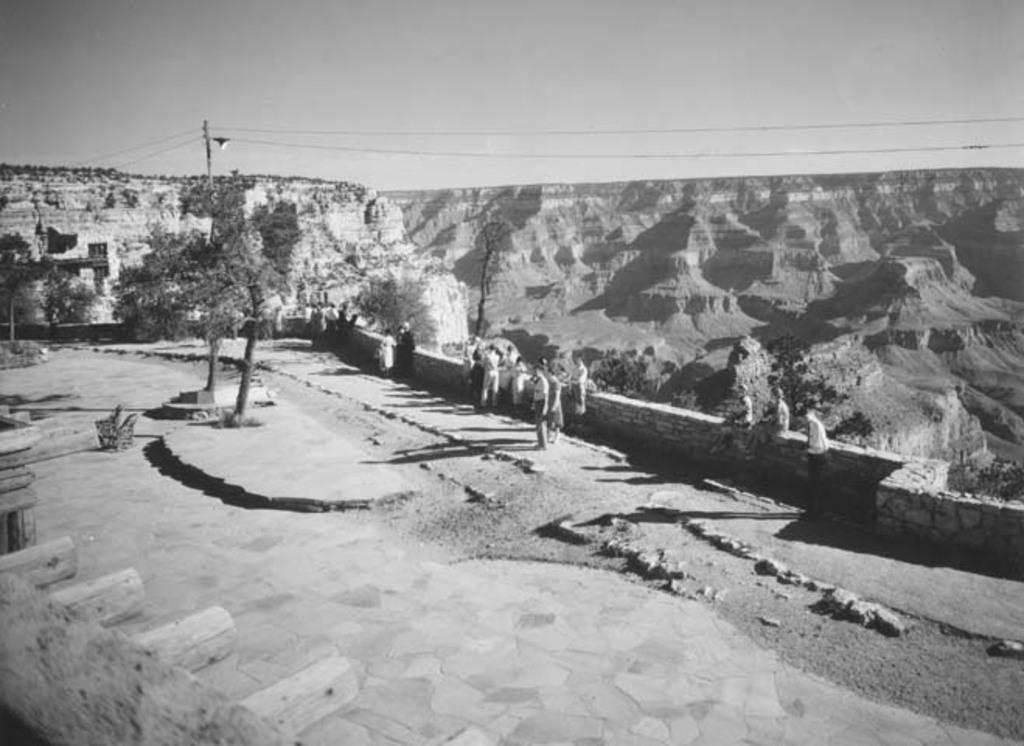What is the color scheme of the image? The image is black and white. What can be seen in the image? There are people, a wall, trees, a pole, a light, hills, and wires in the image. What is visible in the background of the image? The sky is visible in the background of the image. What type of tax is being discussed by the people in the image? There is no indication in the image that the people are discussing any type of tax. Can you tell me how many beads are on the pole in the image? There are no beads present on the pole in the image. 